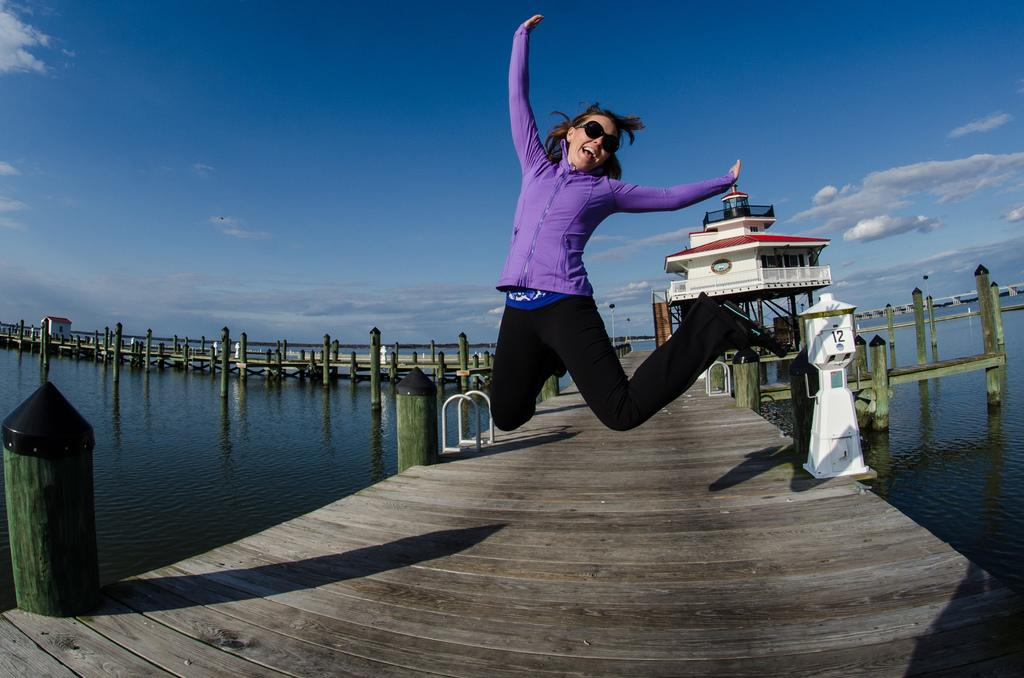What natural feature is present in the image? There is a river in the image. What is located within the river? There is a footpath in the river. What is the lady in the image doing? The lady is jumping on the footpath. What can be seen in the background of the image? The sky is blue in the background of the image. How does the lady's dad react to her jumping on the footpath in the image? There is no information about the lady's dad in the image, so we cannot determine his reaction. 